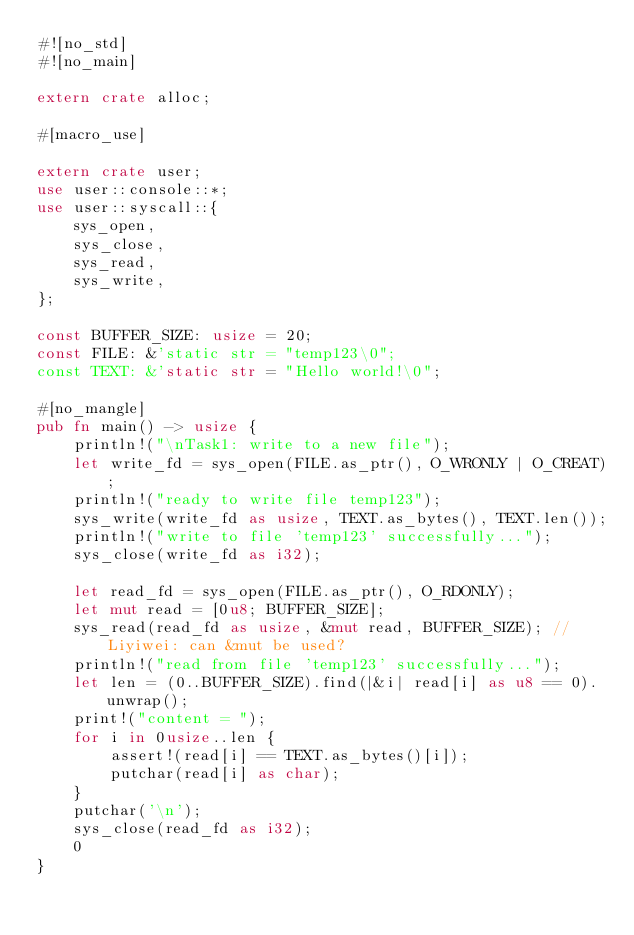Convert code to text. <code><loc_0><loc_0><loc_500><loc_500><_Rust_>#![no_std]
#![no_main]

extern crate alloc;

#[macro_use]

extern crate user;
use user::console::*;
use user::syscall::{
    sys_open,
    sys_close,
    sys_read,
    sys_write,
};

const BUFFER_SIZE: usize = 20;
const FILE: &'static str = "temp123\0";
const TEXT: &'static str = "Hello world!\0";

#[no_mangle]
pub fn main() -> usize {
    println!("\nTask1: write to a new file");
    let write_fd = sys_open(FILE.as_ptr(), O_WRONLY | O_CREAT);
    println!("ready to write file temp123");
    sys_write(write_fd as usize, TEXT.as_bytes(), TEXT.len());
    println!("write to file 'temp123' successfully...");
    sys_close(write_fd as i32);

    let read_fd = sys_open(FILE.as_ptr(), O_RDONLY);
    let mut read = [0u8; BUFFER_SIZE];
    sys_read(read_fd as usize, &mut read, BUFFER_SIZE); // Liyiwei: can &mut be used?
    println!("read from file 'temp123' successfully...");
    let len = (0..BUFFER_SIZE).find(|&i| read[i] as u8 == 0).unwrap();
    print!("content = ");
    for i in 0usize..len {
        assert!(read[i] == TEXT.as_bytes()[i]);
        putchar(read[i] as char);
    }
    putchar('\n');
    sys_close(read_fd as i32);
    0
}
</code> 